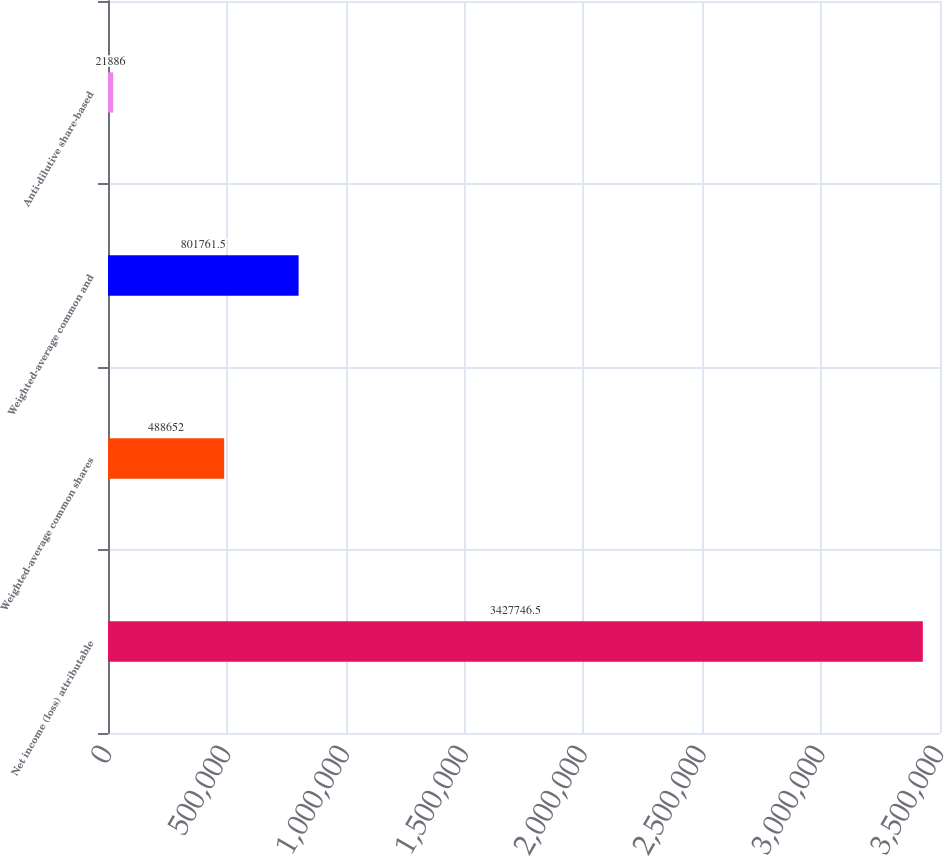<chart> <loc_0><loc_0><loc_500><loc_500><bar_chart><fcel>Net income (loss) attributable<fcel>Weighted-average common shares<fcel>Weighted-average common and<fcel>Anti-dilutive share-based<nl><fcel>3.42775e+06<fcel>488652<fcel>801762<fcel>21886<nl></chart> 